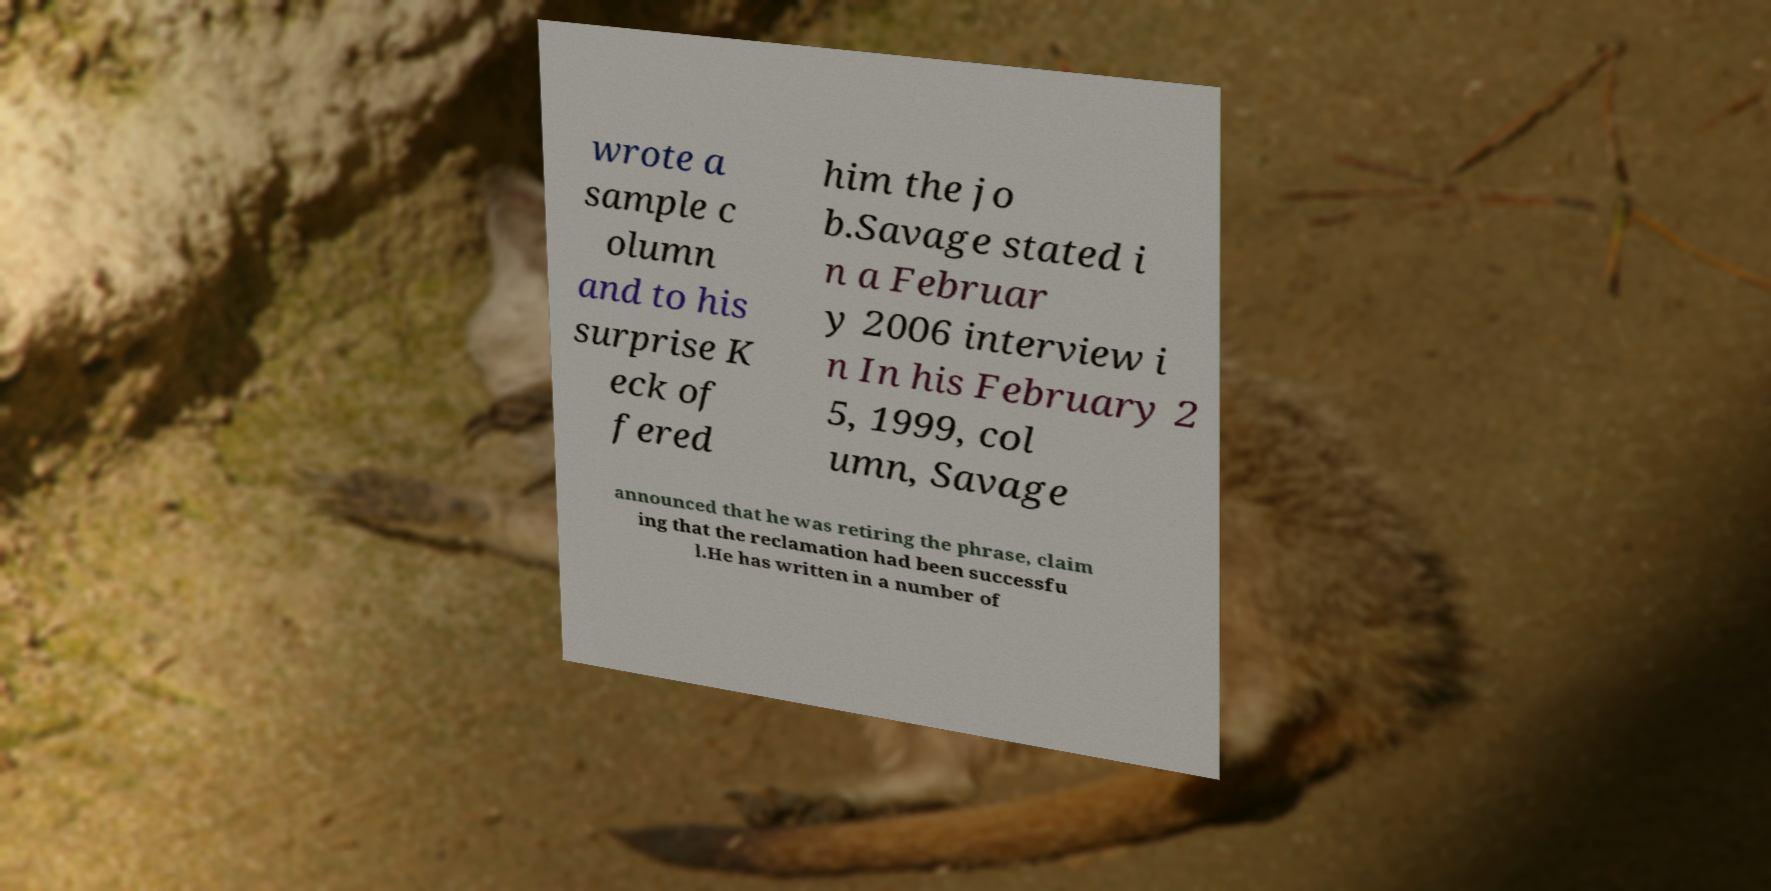Could you assist in decoding the text presented in this image and type it out clearly? wrote a sample c olumn and to his surprise K eck of fered him the jo b.Savage stated i n a Februar y 2006 interview i n In his February 2 5, 1999, col umn, Savage announced that he was retiring the phrase, claim ing that the reclamation had been successfu l.He has written in a number of 